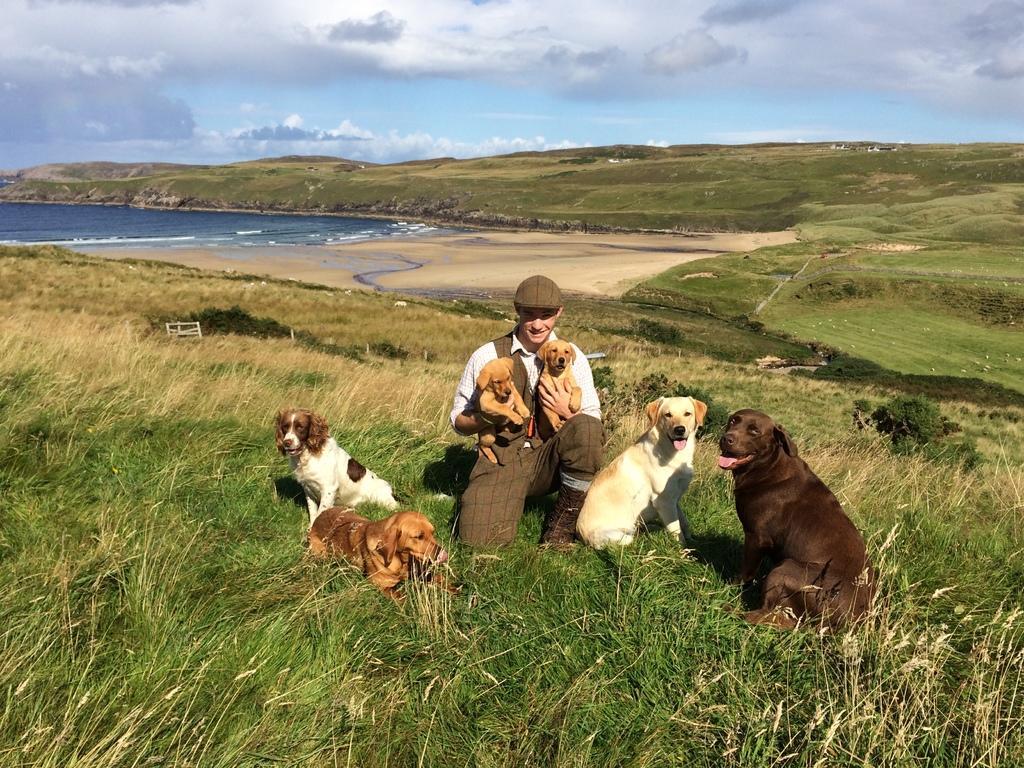In one or two sentences, can you explain what this image depicts? In this picture we can see a man and six dogs in the front, at the bottom there is grass, on the left side we can see water, there is the sky and clouds at the top of the picture, this man is carrying two dogs. 